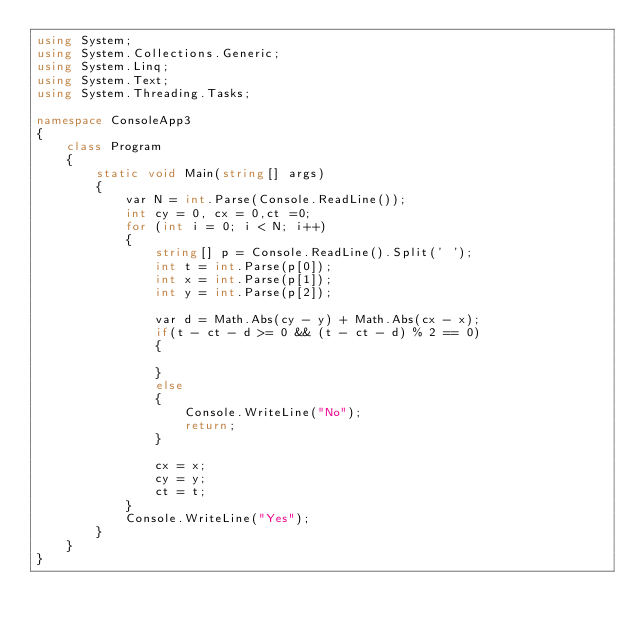Convert code to text. <code><loc_0><loc_0><loc_500><loc_500><_C#_>using System;
using System.Collections.Generic;
using System.Linq;
using System.Text;
using System.Threading.Tasks;

namespace ConsoleApp3
{
    class Program
    {
        static void Main(string[] args)
        {
            var N = int.Parse(Console.ReadLine());
            int cy = 0, cx = 0,ct =0;
            for (int i = 0; i < N; i++)
            {
                string[] p = Console.ReadLine().Split(' ');
                int t = int.Parse(p[0]);
                int x = int.Parse(p[1]);
                int y = int.Parse(p[2]);

                var d = Math.Abs(cy - y) + Math.Abs(cx - x);
                if(t - ct - d >= 0 && (t - ct - d) % 2 == 0)
                {

                }
                else
                {
                    Console.WriteLine("No");
                    return;
                }

                cx = x;
                cy = y;
                ct = t;
            }
            Console.WriteLine("Yes");
        }
    }
}
</code> 